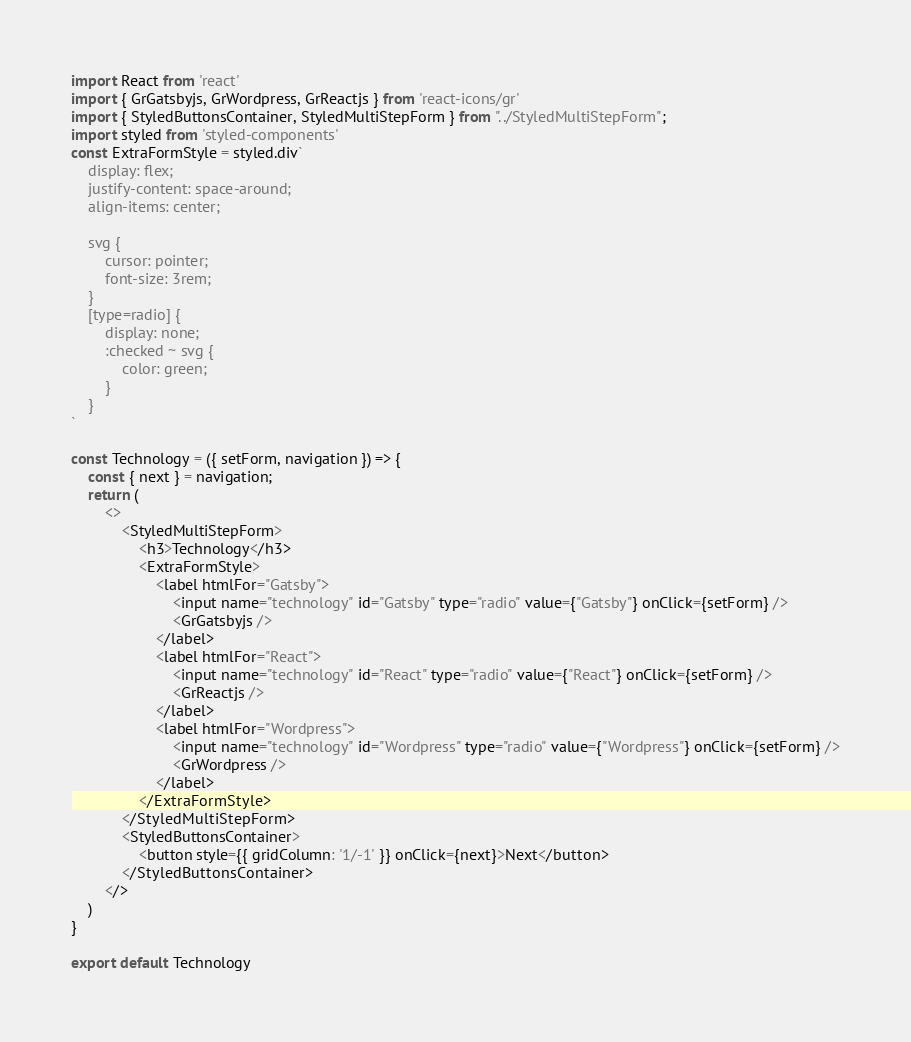Convert code to text. <code><loc_0><loc_0><loc_500><loc_500><_JavaScript_>import React from 'react'
import { GrGatsbyjs, GrWordpress, GrReactjs } from 'react-icons/gr'
import { StyledButtonsContainer, StyledMultiStepForm } from "../StyledMultiStepForm";
import styled from 'styled-components'
const ExtraFormStyle = styled.div`
    display: flex;
    justify-content: space-around;
    align-items: center;
   
    svg {
        cursor: pointer;
        font-size: 3rem;
    }
    [type=radio] {
        display: none;
        :checked ~ svg {
            color: green;
        }
    }
`

const Technology = ({ setForm, navigation }) => {
    const { next } = navigation;
    return (
        <>
            <StyledMultiStepForm>
                <h3>Technology</h3>
                <ExtraFormStyle>
                    <label htmlFor="Gatsby">
                        <input name="technology" id="Gatsby" type="radio" value={"Gatsby"} onClick={setForm} />
                        <GrGatsbyjs />
                    </label>
                    <label htmlFor="React">
                        <input name="technology" id="React" type="radio" value={"React"} onClick={setForm} />
                        <GrReactjs />
                    </label>
                    <label htmlFor="Wordpress">
                        <input name="technology" id="Wordpress" type="radio" value={"Wordpress"} onClick={setForm} />
                        <GrWordpress />
                    </label>
                </ExtraFormStyle>
            </StyledMultiStepForm>
            <StyledButtonsContainer>
                <button style={{ gridColumn: '1/-1' }} onClick={next}>Next</button>
            </StyledButtonsContainer>
        </>
    )
}

export default Technology
</code> 